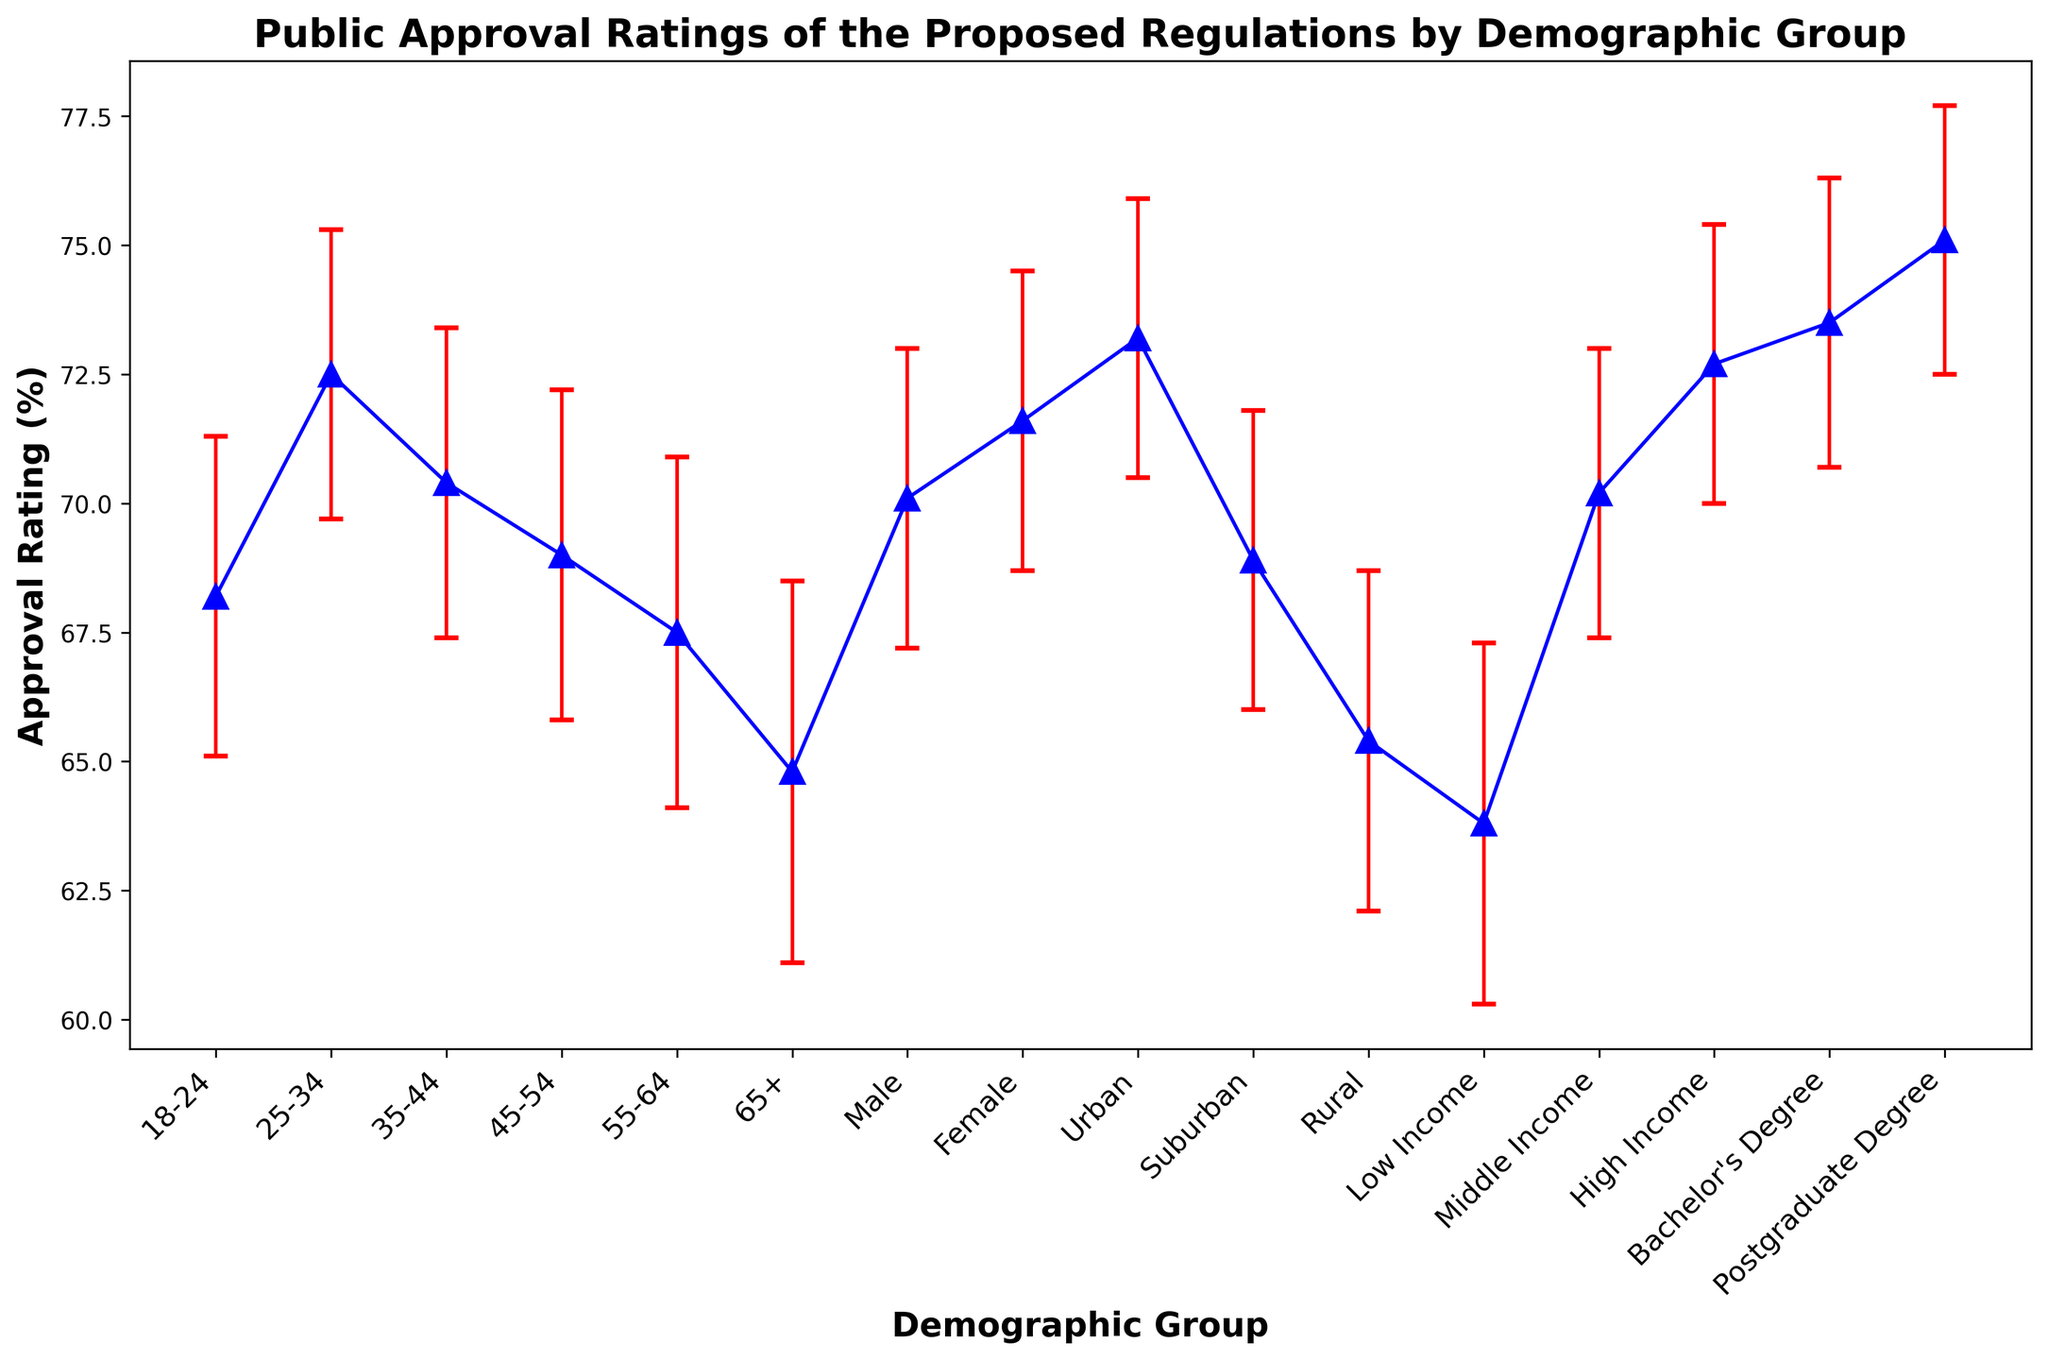What is the average approval rating for the age groups under 35? To find the average approval rating for the age groups under 35 (18-24 and 25-34), sum the approval ratings (68.2 + 72.5) and then divide by the number of groups, which is 2. So, the average is (68.2 + 72.5) / 2.
Answer: 70.35 Which demographic group has the highest approval rating and what is the value? By examining the approval ratings, the demographic group with the highest rating is the Postgraduate Degree group with a value of 75.1.
Answer: Postgraduate Degree, 75.1 How does the approval rating for the Rural group compare to the Urban group? Compare the approval rating values of the Rural group (65.4) and the Urban group (73.2). The Urban group's approval rating is higher than the Rural group's by 73.2 - 65.4 = 7.8.
Answer: Urban is 7.8 higher than Rural What is the difference in approval ratings between the highest and lowest income groups? Subtract the approval rating of the Low Income group (63.8) from the approval rating of the High Income group (72.7). The difference is 72.7 - 63.8.
Answer: 8.9 Identify the demographic group with the lowest approval rating and state the value. The group with the lowest approval rating is the Low Income group with a value of 63.8.
Answer: Low Income, 63.8 What is the range of approval ratings within the education level categories? Identify the highest (Postgraduate Degree, 75.1) and lowest (Bachelor's Degree, 73.5) approval ratings within the education categories. The range is 75.1 - 73.5.
Answer: 1.6 How do the standard errors of approval ratings for different income groups compare? The standard errors for Low Income, Middle Income, and High Income groups are 3.5, 2.8, and 2.7, respectively. The Low Income group has the highest standard error, and the High Income group has the lowest.
Answer: Low Income highest, High Income lowest What is the average approval rating for the gender categories? To find the average approval rating for the gender categories (Male and Female), sum the approval ratings (70.1 + 71.6) and divide by 2. So, the average is (70.1 + 71.6) / 2.
Answer: 70.85 Which demographic group has a standard error of exactly 2.7? The groups with a standard error of 2.7 are the Urban group and the High Income group.
Answer: Urban and High Income What percentage difference is there between the approval ratings of Suburban and Rural groups? Calculate the percentage difference between Suburban (68.9) and Rural (65.4) groups. The difference in approval ratings is 68.9 - 65.4 = 3.5. Percentage difference is (3.5 / 65.4) * 100.
Answer: 5.35% 